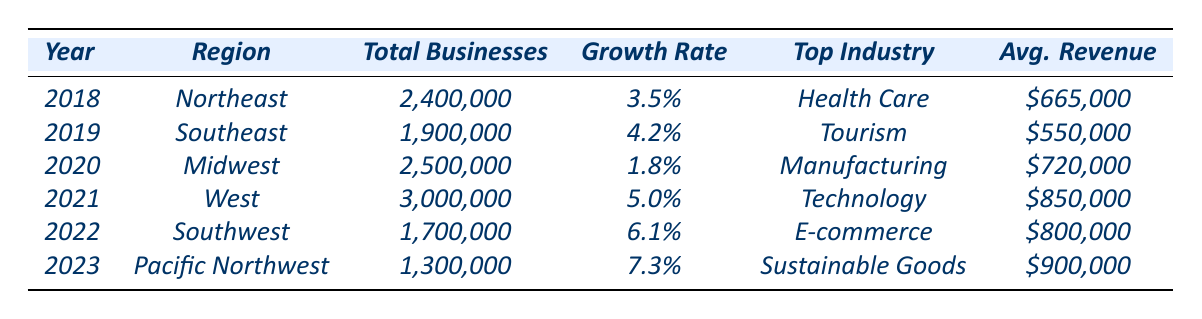What was the total number of businesses in the West region in 2021? The table shows the total number of businesses in the West region for the year 2021 as 3,000,000.
Answer: 3,000,000 Which industry had the highest average revenue in 2023? According to the table, the Sustainable Goods industry had the highest average revenue in 2023, which is $900,000.
Answer: $900,000 What is the average growth rate from 2018 to 2023? The growth rates from 2018 to 2023 are 3.5%, 4.2%, 1.8%, 5.0%, 6.1%, and 7.3%. Adding these gives a total of 28.9%. Dividing by 6 years results in an average growth rate of approximately 4.82%.
Answer: 4.82% Did the total number of businesses in the Northeast increase or decrease between 2018 and 2023? The total number of businesses in the Northeast in 2018 was 2,400,000, and in 2023 it is not present (since the entry is for a different region), so there’s no direct comparison for this region in 2023.
Answer: No comparison available What was the percentage increase in total businesses from 2019 in the Southeast to 2021 in the West? The total businesses in the Southeast in 2019 was 1,900,000, while in the West in 2021 it was 3,000,000. The increase can be calculated as (3,000,000 - 1,900,000) / 1,900,000 * 100% which equals approximately 57.89%.
Answer: 57.89% Which region experienced the most significant growth rate in 2022 compared to 2021? In 2021, the West had a growth rate of 5.0%, and in 2022, the Southwest had a growth rate of 6.1%. Thus, the Southwest experienced more growth compared to the previous year.
Answer: Southwest How many total businesses were there in the Midwest in 2020? The table states that in 2020, the Midwest had a total of 2,500,000 businesses.
Answer: 2,500,000 Which region had the top industry in Health Care, and in what year? The Northeast region had Health Care as the top industry in the year 2018.
Answer: Northeast, 2018 What is the change in average revenue from 2018 to 2023? The average revenue in 2018 was $665,000, and in 2023 it is $900,000. The change is calculated as $900,000 - $665,000 = $235,000.
Answer: $235,000 Was the business growth rate higher in 2023 than in any other year listed? Yes, in 2023, the growth rate of 7.3% is higher than all previous years listed.
Answer: Yes 